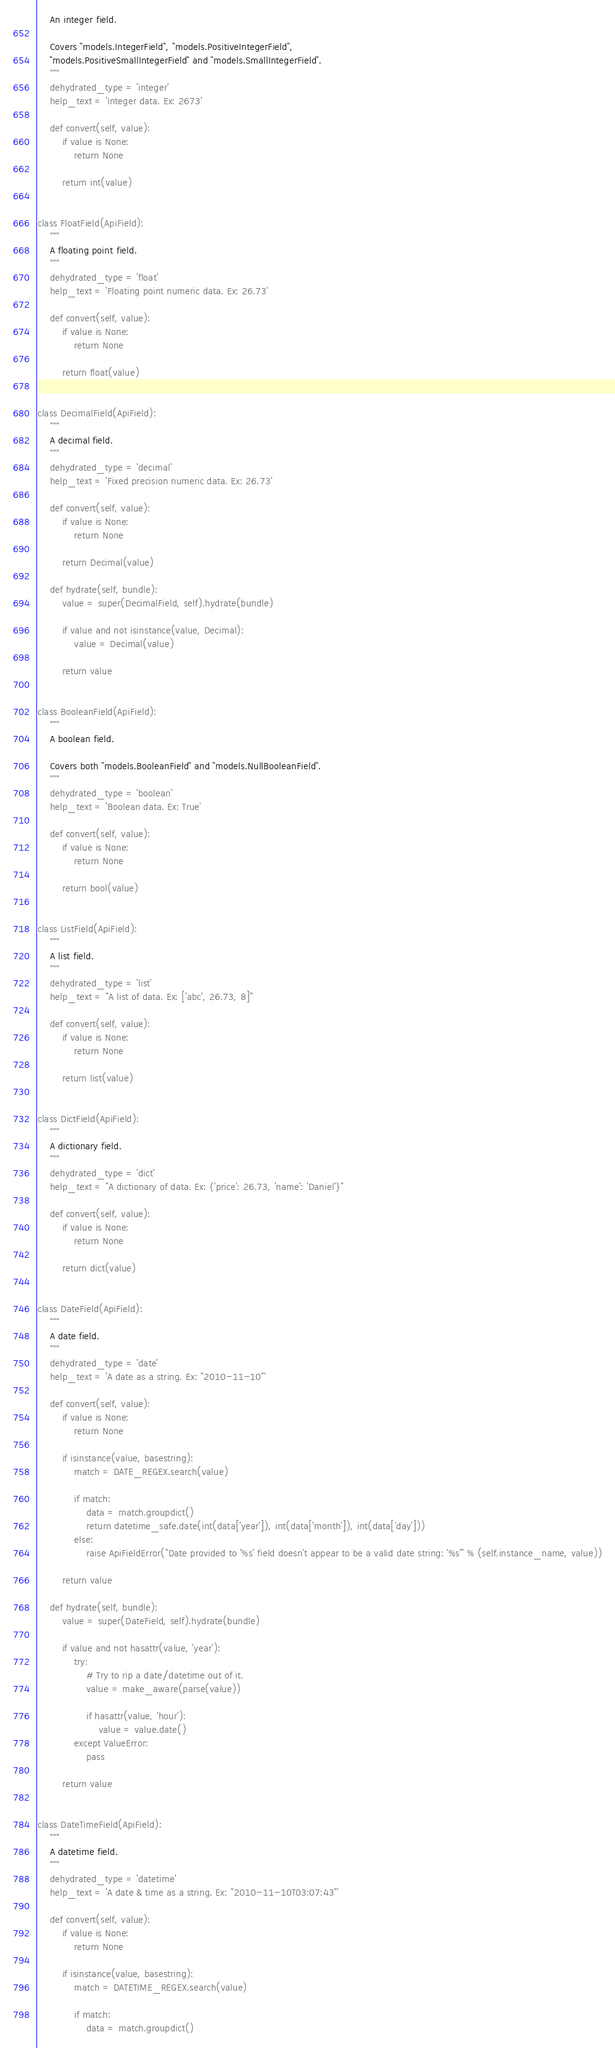<code> <loc_0><loc_0><loc_500><loc_500><_Python_>    An integer field.

    Covers ``models.IntegerField``, ``models.PositiveIntegerField``,
    ``models.PositiveSmallIntegerField`` and ``models.SmallIntegerField``.
    """
    dehydrated_type = 'integer'
    help_text = 'Integer data. Ex: 2673'

    def convert(self, value):
        if value is None:
            return None

        return int(value)


class FloatField(ApiField):
    """
    A floating point field.
    """
    dehydrated_type = 'float'
    help_text = 'Floating point numeric data. Ex: 26.73'

    def convert(self, value):
        if value is None:
            return None

        return float(value)


class DecimalField(ApiField):
    """
    A decimal field.
    """
    dehydrated_type = 'decimal'
    help_text = 'Fixed precision numeric data. Ex: 26.73'

    def convert(self, value):
        if value is None:
            return None

        return Decimal(value)

    def hydrate(self, bundle):
        value = super(DecimalField, self).hydrate(bundle)

        if value and not isinstance(value, Decimal):
            value = Decimal(value)

        return value


class BooleanField(ApiField):
    """
    A boolean field.

    Covers both ``models.BooleanField`` and ``models.NullBooleanField``.
    """
    dehydrated_type = 'boolean'
    help_text = 'Boolean data. Ex: True'

    def convert(self, value):
        if value is None:
            return None

        return bool(value)


class ListField(ApiField):
    """
    A list field.
    """
    dehydrated_type = 'list'
    help_text = "A list of data. Ex: ['abc', 26.73, 8]"

    def convert(self, value):
        if value is None:
            return None

        return list(value)


class DictField(ApiField):
    """
    A dictionary field.
    """
    dehydrated_type = 'dict'
    help_text = "A dictionary of data. Ex: {'price': 26.73, 'name': 'Daniel'}"

    def convert(self, value):
        if value is None:
            return None

        return dict(value)


class DateField(ApiField):
    """
    A date field.
    """
    dehydrated_type = 'date'
    help_text = 'A date as a string. Ex: "2010-11-10"'

    def convert(self, value):
        if value is None:
            return None

        if isinstance(value, basestring):
            match = DATE_REGEX.search(value)

            if match:
                data = match.groupdict()
                return datetime_safe.date(int(data['year']), int(data['month']), int(data['day']))
            else:
                raise ApiFieldError("Date provided to '%s' field doesn't appear to be a valid date string: '%s'" % (self.instance_name, value))

        return value

    def hydrate(self, bundle):
        value = super(DateField, self).hydrate(bundle)

        if value and not hasattr(value, 'year'):
            try:
                # Try to rip a date/datetime out of it.
                value = make_aware(parse(value))

                if hasattr(value, 'hour'):
                    value = value.date()
            except ValueError:
                pass

        return value


class DateTimeField(ApiField):
    """
    A datetime field.
    """
    dehydrated_type = 'datetime'
    help_text = 'A date & time as a string. Ex: "2010-11-10T03:07:43"'

    def convert(self, value):
        if value is None:
            return None

        if isinstance(value, basestring):
            match = DATETIME_REGEX.search(value)

            if match:
                data = match.groupdict()</code> 